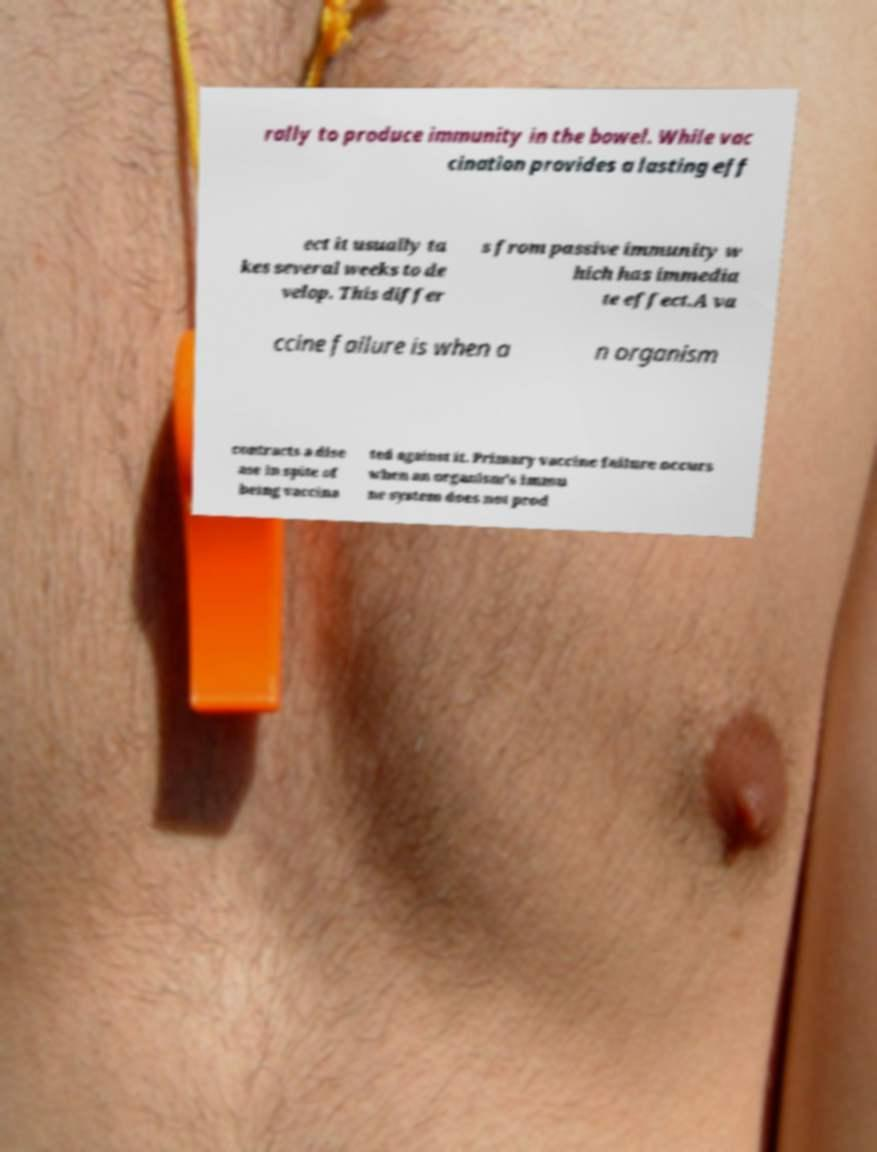Could you extract and type out the text from this image? rally to produce immunity in the bowel. While vac cination provides a lasting eff ect it usually ta kes several weeks to de velop. This differ s from passive immunity w hich has immedia te effect.A va ccine failure is when a n organism contracts a dise ase in spite of being vaccina ted against it. Primary vaccine failure occurs when an organism's immu ne system does not prod 